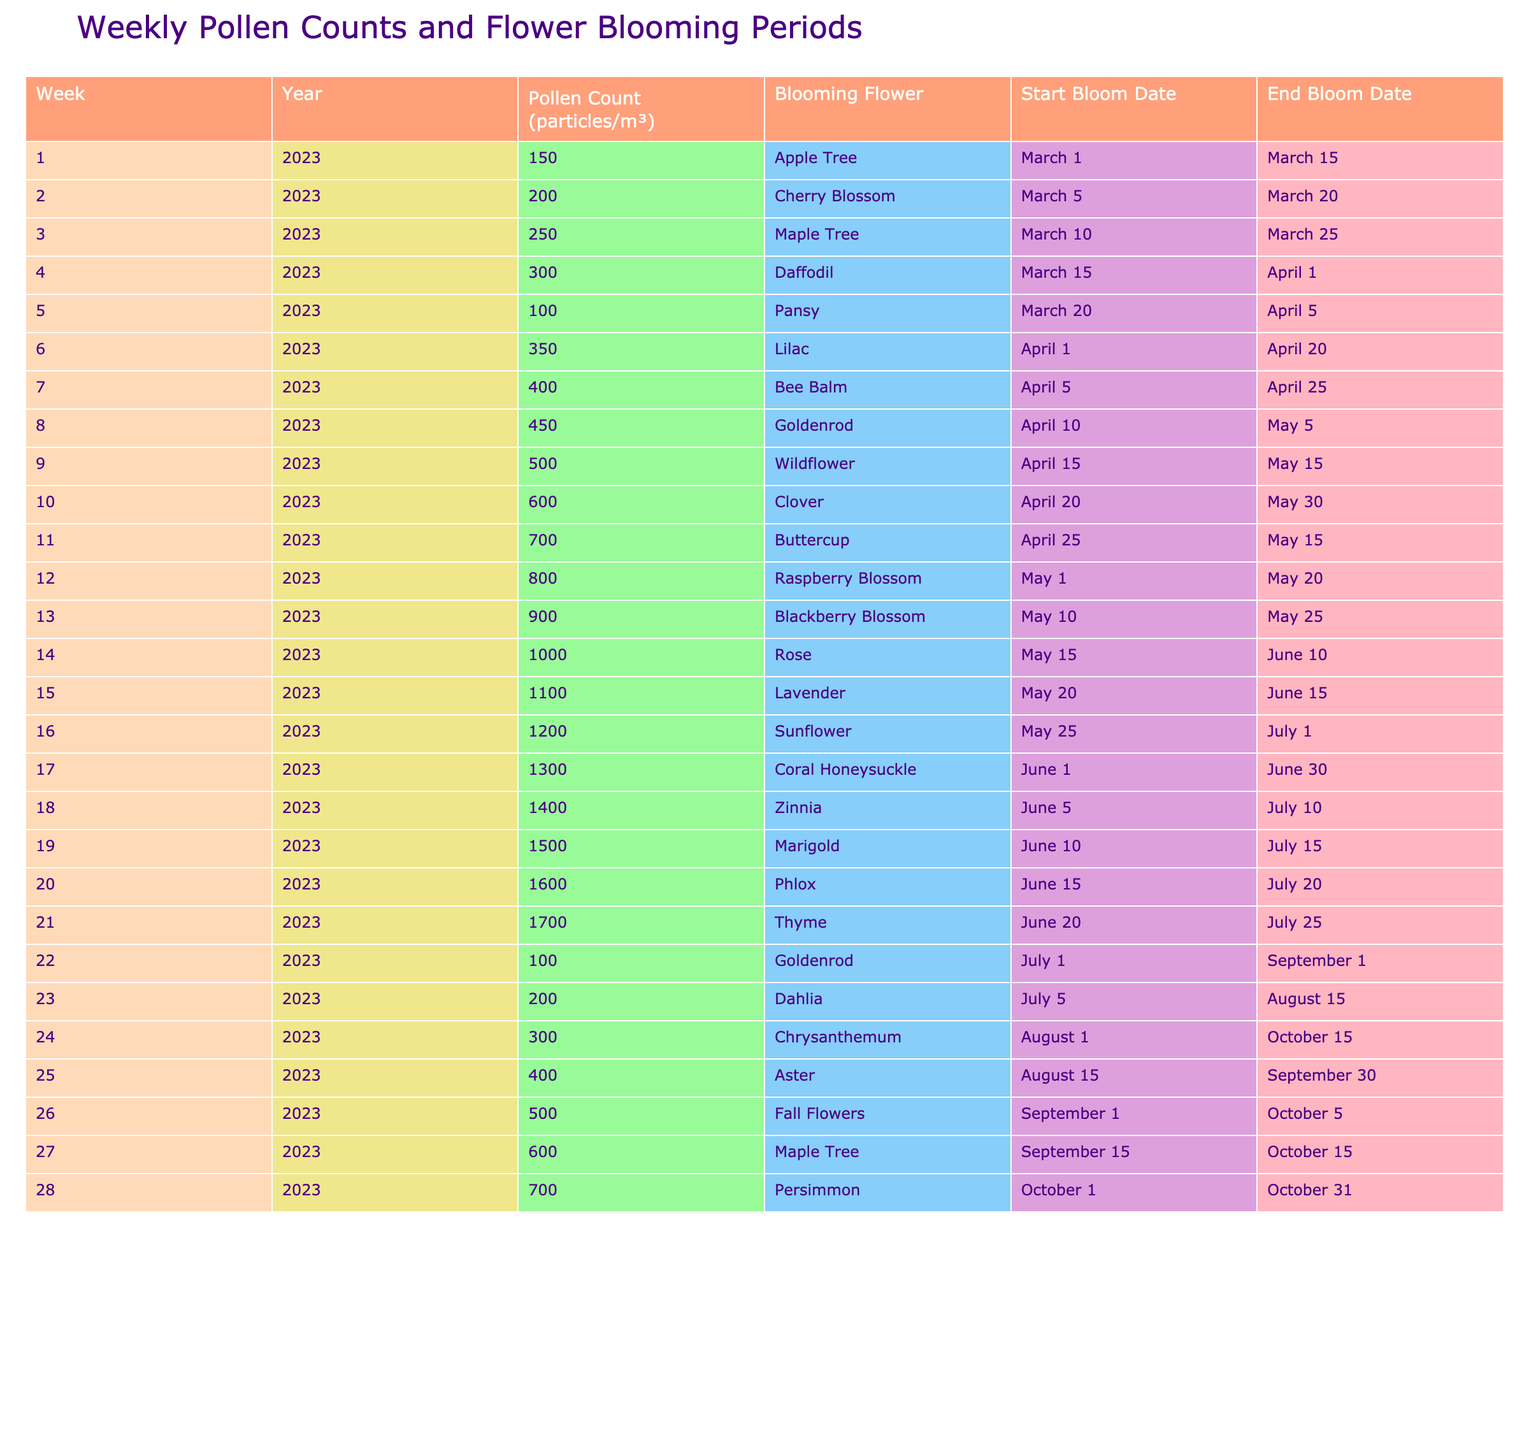What is the pollen count in Week 10 of 2023? From the table, we look for the row corresponding to Week 10 in 2023. The pollen count in that row is 600 particles/m³.
Answer: 600 Which flower has the highest pollen count, and what is that count? By scanning the pollen count column of the table, we find that the highest value is 1300, which corresponds to the Coral Honeysuckle.
Answer: Coral Honeysuckle, 1300 What is the duration of the Raspberry Blossom's blooming period? The blooming period for Raspberry Blossom starts on May 1 and ends on May 20. To find the duration, we calculate the days from May 1 to May 20, which is 20 days.
Answer: 20 days Is the Apple Tree blooming period earlier than that of the Cherry Blossom? The Apple Tree blooms from March 1 to March 15, while the Cherry Blossom blooms from March 5 to March 20. Since March 1 is earlier than March 5, the Apple Tree's blooming period is earlier.
Answer: Yes What is the average pollen count for the weeks where Lilac and Bee Balm are blooming? The pollen counts during the blooming periods are 350 (Lilac) and 400 (Bee Balm). To find the average, we sum these two values: 350 + 400 = 750, and then divide by 2, giving us 750/2 = 375.
Answer: 375 How many different flowers bloom in June, and what are their names? Reviewing the table for June, we note that the flowers blooming in this month are Coral Honeysuckle, Zinnia, Marigold, Phlox, and Thyme, totaling five flowers.
Answer: 5 flowers: Coral Honeysuckle, Zinnia, Marigold, Phlox, Thyme What is the total pollen count from Weeks 22 to 24? The pollen counts for those weeks are 100 (Week 22), 200 (Week 23), and 300 (Week 24). Adding these values together: 100 + 200 + 300 = 600.
Answer: 600 Which flower blooms at the same time as Thyme and what is its pollen count? Thyme blooms from June 20 to July 25. The only flower blooming during that same period is Goldenrod, with a pollen count of 100 on July 1.
Answer: Goldenrod, 100 Which blooming flower has the longest duration, and how long is it? The flowers and their durations need to be checked, and we find that the Lavender has a blooming period from May 20 to June 15, which spans 26 days. Other flowers do not exceed this duration.
Answer: Lavender, 26 days 